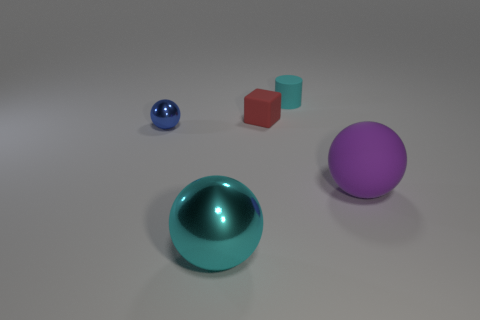Add 4 tiny blue balls. How many objects exist? 9 Subtract 0 green spheres. How many objects are left? 5 Subtract all blocks. How many objects are left? 4 Subtract all red balls. Subtract all brown cylinders. How many balls are left? 3 Subtract all blue cylinders. How many purple balls are left? 1 Subtract all large cyan balls. Subtract all blue spheres. How many objects are left? 3 Add 5 small rubber things. How many small rubber things are left? 7 Add 2 purple rubber things. How many purple rubber things exist? 3 Subtract all cyan spheres. How many spheres are left? 2 Subtract all blue spheres. How many spheres are left? 2 